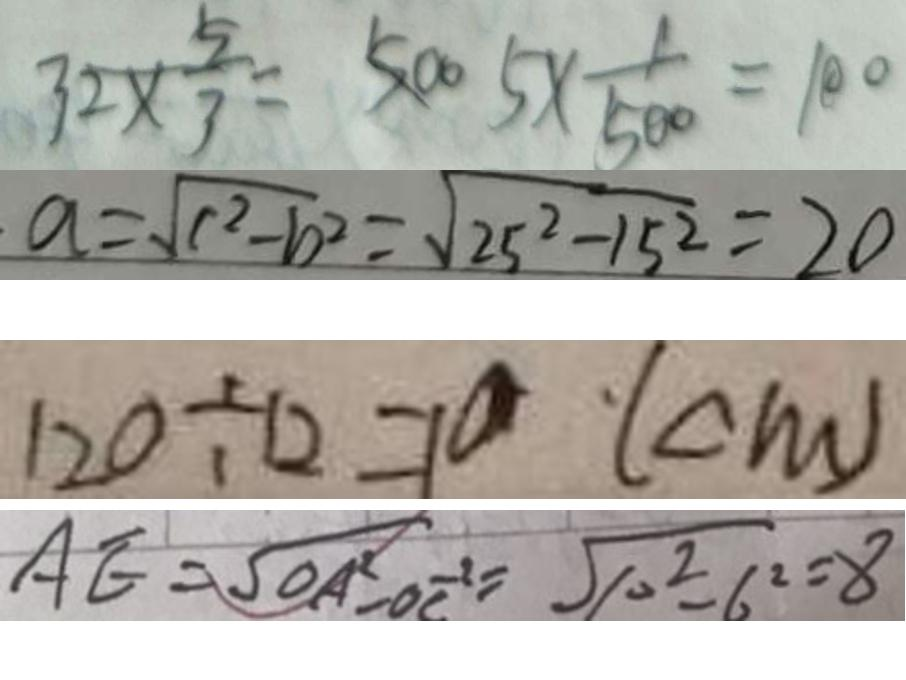<formula> <loc_0><loc_0><loc_500><loc_500>3 2 \times \frac { 5 } { 3 } = 5 0 0 5 \times \frac { 1 } { 5 0 0 } = 1 0 0 
 a = \sqrt { c ^ { 2 } - b ^ { 2 } } = \sqrt { 2 5 ^ { 2 } - 1 5 ^ { 2 } } = 2 0 
 1 2 0 \div 1 2 = 1 0 ( c m ) 
 A E = \sqrt { O A ^ { 2 } - O C ^ { - 2 } } = \sqrt { 1 0 ^ { 2 } - 6 ^ { 2 } } = 8</formula> 